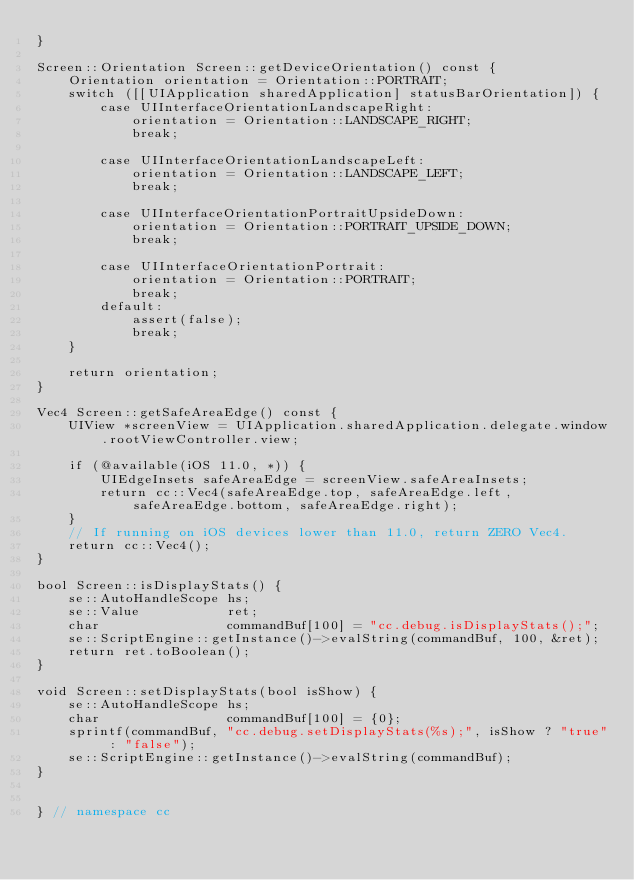<code> <loc_0><loc_0><loc_500><loc_500><_ObjectiveC_>}

Screen::Orientation Screen::getDeviceOrientation() const {
    Orientation orientation = Orientation::PORTRAIT;
    switch ([[UIApplication sharedApplication] statusBarOrientation]) {
        case UIInterfaceOrientationLandscapeRight:
            orientation = Orientation::LANDSCAPE_RIGHT;
            break;

        case UIInterfaceOrientationLandscapeLeft:
            orientation = Orientation::LANDSCAPE_LEFT;
            break;

        case UIInterfaceOrientationPortraitUpsideDown:
            orientation = Orientation::PORTRAIT_UPSIDE_DOWN;
            break;

        case UIInterfaceOrientationPortrait:
            orientation = Orientation::PORTRAIT;
            break;
        default:
            assert(false);
            break;
    }

    return orientation;
}

Vec4 Screen::getSafeAreaEdge() const {
    UIView *screenView = UIApplication.sharedApplication.delegate.window.rootViewController.view;

    if (@available(iOS 11.0, *)) {
        UIEdgeInsets safeAreaEdge = screenView.safeAreaInsets;
        return cc::Vec4(safeAreaEdge.top, safeAreaEdge.left, safeAreaEdge.bottom, safeAreaEdge.right);
    }
    // If running on iOS devices lower than 11.0, return ZERO Vec4.
    return cc::Vec4();
}

bool Screen::isDisplayStats() {
    se::AutoHandleScope hs;
    se::Value           ret;
    char                commandBuf[100] = "cc.debug.isDisplayStats();";
    se::ScriptEngine::getInstance()->evalString(commandBuf, 100, &ret);
    return ret.toBoolean();
}

void Screen::setDisplayStats(bool isShow) {
    se::AutoHandleScope hs;
    char                commandBuf[100] = {0};
    sprintf(commandBuf, "cc.debug.setDisplayStats(%s);", isShow ? "true" : "false");
    se::ScriptEngine::getInstance()->evalString(commandBuf);
}


} // namespace cc
</code> 